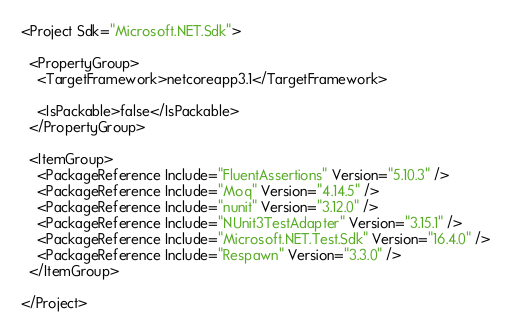Convert code to text. <code><loc_0><loc_0><loc_500><loc_500><_XML_><Project Sdk="Microsoft.NET.Sdk">

  <PropertyGroup>
    <TargetFramework>netcoreapp3.1</TargetFramework>

    <IsPackable>false</IsPackable>
  </PropertyGroup>

  <ItemGroup>
    <PackageReference Include="FluentAssertions" Version="5.10.3" />
    <PackageReference Include="Moq" Version="4.14.5" />
    <PackageReference Include="nunit" Version="3.12.0" />
    <PackageReference Include="NUnit3TestAdapter" Version="3.15.1" />
    <PackageReference Include="Microsoft.NET.Test.Sdk" Version="16.4.0" />
    <PackageReference Include="Respawn" Version="3.3.0" />
  </ItemGroup>

</Project>
</code> 